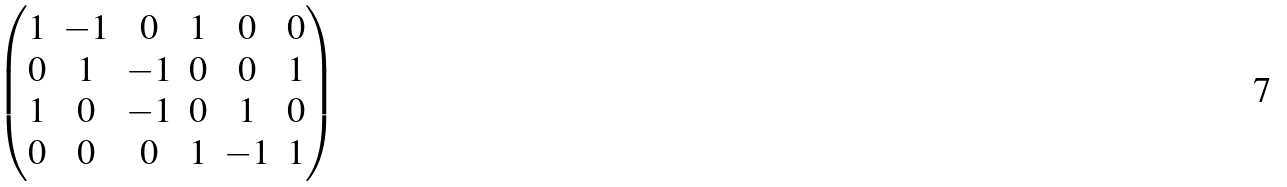<formula> <loc_0><loc_0><loc_500><loc_500>\begin{pmatrix} 1 & - 1 & 0 & 1 & 0 & 0 \\ 0 & 1 & - 1 & 0 & 0 & 1 \\ 1 & 0 & - 1 & 0 & 1 & 0 \\ 0 & 0 & 0 & 1 & - 1 & 1 \end{pmatrix}</formula> 